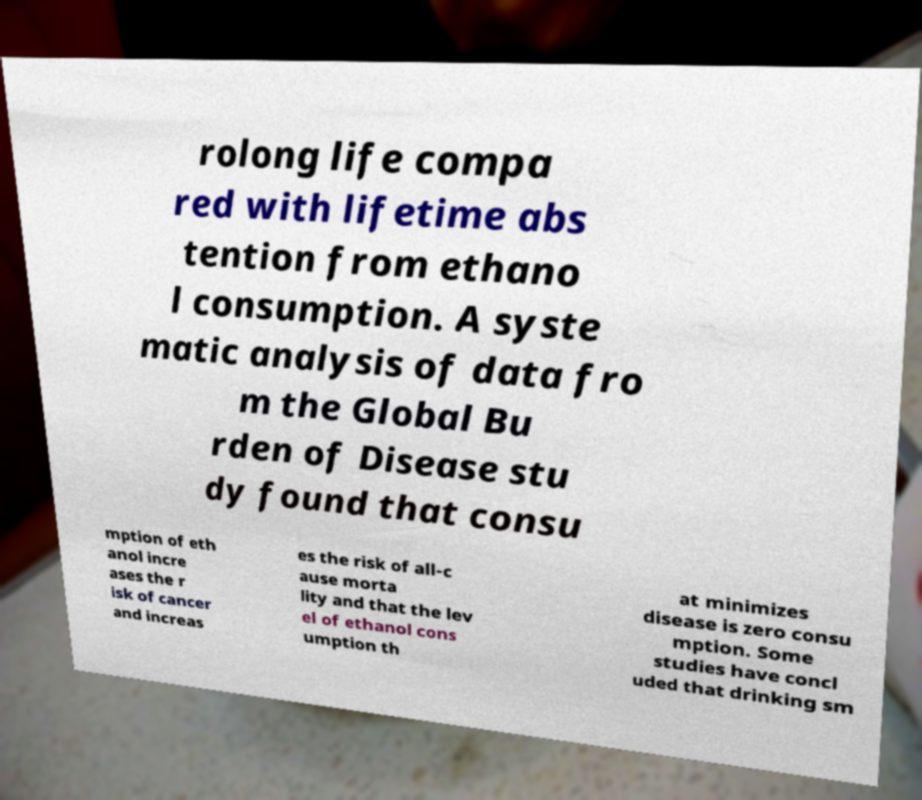For documentation purposes, I need the text within this image transcribed. Could you provide that? rolong life compa red with lifetime abs tention from ethano l consumption. A syste matic analysis of data fro m the Global Bu rden of Disease stu dy found that consu mption of eth anol incre ases the r isk of cancer and increas es the risk of all-c ause morta lity and that the lev el of ethanol cons umption th at minimizes disease is zero consu mption. Some studies have concl uded that drinking sm 